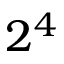Convert formula to latex. <formula><loc_0><loc_0><loc_500><loc_500>2 ^ { 4 }</formula> 